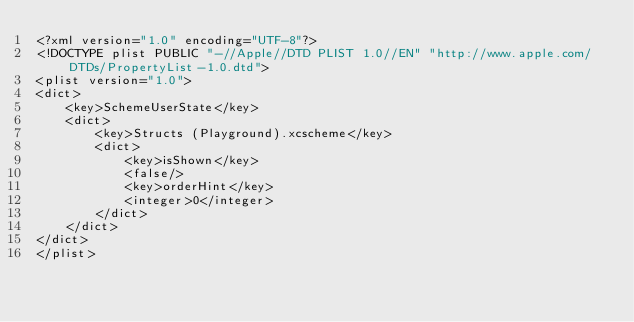<code> <loc_0><loc_0><loc_500><loc_500><_XML_><?xml version="1.0" encoding="UTF-8"?>
<!DOCTYPE plist PUBLIC "-//Apple//DTD PLIST 1.0//EN" "http://www.apple.com/DTDs/PropertyList-1.0.dtd">
<plist version="1.0">
<dict>
	<key>SchemeUserState</key>
	<dict>
		<key>Structs (Playground).xcscheme</key>
		<dict>
			<key>isShown</key>
			<false/>
			<key>orderHint</key>
			<integer>0</integer>
		</dict>
	</dict>
</dict>
</plist>
</code> 